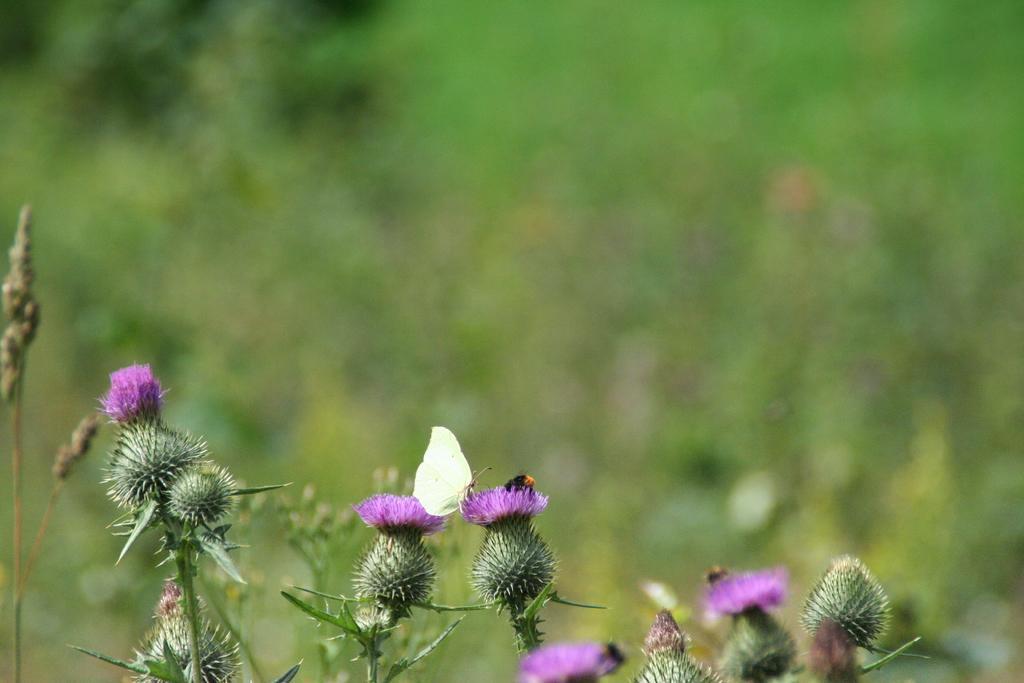Could you give a brief overview of what you see in this image? Here we can see flowers and a butterfly. There is a blur background with greenery. 